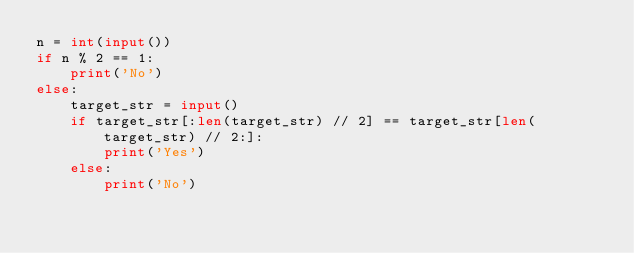<code> <loc_0><loc_0><loc_500><loc_500><_Python_>n = int(input())
if n % 2 == 1:
    print('No')
else:
    target_str = input()
    if target_str[:len(target_str) // 2] == target_str[len(target_str) // 2:]:
        print('Yes')
    else:
        print('No')</code> 